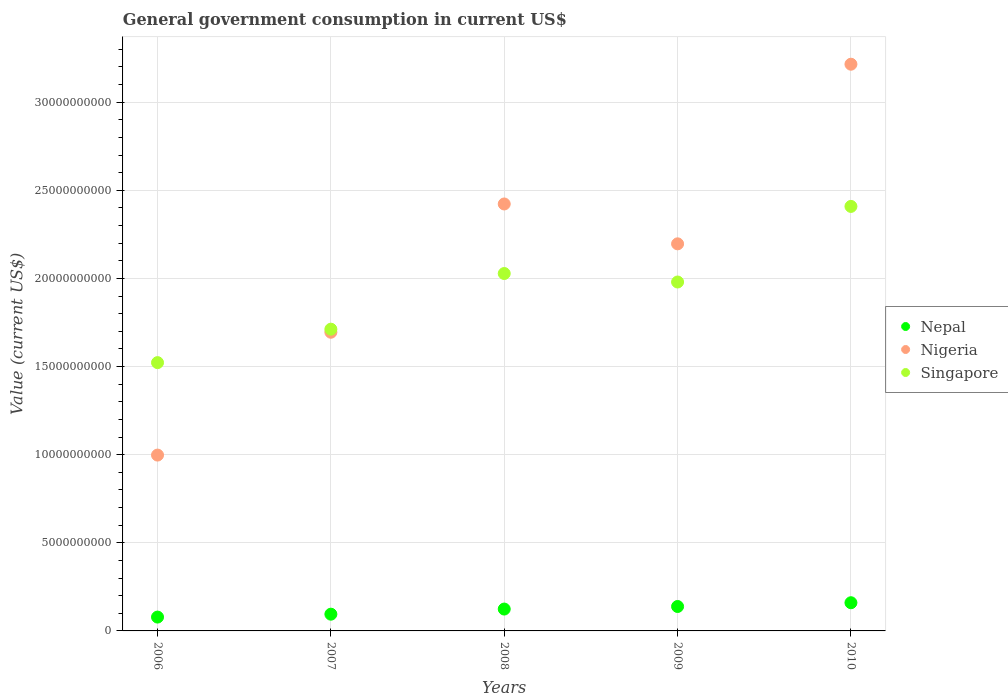How many different coloured dotlines are there?
Offer a terse response. 3. Is the number of dotlines equal to the number of legend labels?
Offer a very short reply. Yes. What is the government conusmption in Singapore in 2006?
Your answer should be very brief. 1.52e+1. Across all years, what is the maximum government conusmption in Nepal?
Give a very brief answer. 1.60e+09. Across all years, what is the minimum government conusmption in Singapore?
Your answer should be very brief. 1.52e+1. What is the total government conusmption in Nepal in the graph?
Your answer should be compact. 5.96e+09. What is the difference between the government conusmption in Singapore in 2009 and that in 2010?
Your response must be concise. -4.29e+09. What is the difference between the government conusmption in Singapore in 2009 and the government conusmption in Nepal in 2010?
Ensure brevity in your answer.  1.82e+1. What is the average government conusmption in Singapore per year?
Offer a terse response. 1.93e+1. In the year 2008, what is the difference between the government conusmption in Nepal and government conusmption in Nigeria?
Make the answer very short. -2.30e+1. In how many years, is the government conusmption in Nigeria greater than 16000000000 US$?
Offer a terse response. 4. What is the ratio of the government conusmption in Nepal in 2008 to that in 2009?
Keep it short and to the point. 0.9. Is the government conusmption in Singapore in 2006 less than that in 2007?
Provide a short and direct response. Yes. What is the difference between the highest and the second highest government conusmption in Nigeria?
Make the answer very short. 7.93e+09. What is the difference between the highest and the lowest government conusmption in Nigeria?
Ensure brevity in your answer.  2.22e+1. In how many years, is the government conusmption in Singapore greater than the average government conusmption in Singapore taken over all years?
Keep it short and to the point. 3. Is the sum of the government conusmption in Singapore in 2008 and 2010 greater than the maximum government conusmption in Nepal across all years?
Offer a very short reply. Yes. Does the government conusmption in Nigeria monotonically increase over the years?
Give a very brief answer. No. Is the government conusmption in Singapore strictly less than the government conusmption in Nigeria over the years?
Your response must be concise. No. How many years are there in the graph?
Keep it short and to the point. 5. What is the difference between two consecutive major ticks on the Y-axis?
Ensure brevity in your answer.  5.00e+09. Are the values on the major ticks of Y-axis written in scientific E-notation?
Your answer should be very brief. No. Where does the legend appear in the graph?
Give a very brief answer. Center right. How many legend labels are there?
Offer a very short reply. 3. How are the legend labels stacked?
Your answer should be very brief. Vertical. What is the title of the graph?
Offer a terse response. General government consumption in current US$. What is the label or title of the X-axis?
Make the answer very short. Years. What is the label or title of the Y-axis?
Your response must be concise. Value (current US$). What is the Value (current US$) of Nepal in 2006?
Your answer should be very brief. 7.85e+08. What is the Value (current US$) in Nigeria in 2006?
Ensure brevity in your answer.  9.98e+09. What is the Value (current US$) in Singapore in 2006?
Your answer should be very brief. 1.52e+1. What is the Value (current US$) in Nepal in 2007?
Your answer should be very brief. 9.50e+08. What is the Value (current US$) in Nigeria in 2007?
Your answer should be compact. 1.69e+1. What is the Value (current US$) of Singapore in 2007?
Offer a very short reply. 1.71e+1. What is the Value (current US$) of Nepal in 2008?
Offer a terse response. 1.24e+09. What is the Value (current US$) in Nigeria in 2008?
Provide a succinct answer. 2.42e+1. What is the Value (current US$) of Singapore in 2008?
Offer a very short reply. 2.03e+1. What is the Value (current US$) in Nepal in 2009?
Ensure brevity in your answer.  1.39e+09. What is the Value (current US$) of Nigeria in 2009?
Offer a terse response. 2.20e+1. What is the Value (current US$) in Singapore in 2009?
Your answer should be compact. 1.98e+1. What is the Value (current US$) of Nepal in 2010?
Make the answer very short. 1.60e+09. What is the Value (current US$) in Nigeria in 2010?
Give a very brief answer. 3.22e+1. What is the Value (current US$) in Singapore in 2010?
Your answer should be compact. 2.41e+1. Across all years, what is the maximum Value (current US$) of Nepal?
Offer a terse response. 1.60e+09. Across all years, what is the maximum Value (current US$) in Nigeria?
Your answer should be very brief. 3.22e+1. Across all years, what is the maximum Value (current US$) of Singapore?
Your answer should be compact. 2.41e+1. Across all years, what is the minimum Value (current US$) of Nepal?
Provide a succinct answer. 7.85e+08. Across all years, what is the minimum Value (current US$) of Nigeria?
Give a very brief answer. 9.98e+09. Across all years, what is the minimum Value (current US$) of Singapore?
Your response must be concise. 1.52e+1. What is the total Value (current US$) of Nepal in the graph?
Make the answer very short. 5.96e+09. What is the total Value (current US$) in Nigeria in the graph?
Give a very brief answer. 1.05e+11. What is the total Value (current US$) of Singapore in the graph?
Ensure brevity in your answer.  9.65e+1. What is the difference between the Value (current US$) in Nepal in 2006 and that in 2007?
Make the answer very short. -1.65e+08. What is the difference between the Value (current US$) of Nigeria in 2006 and that in 2007?
Your answer should be compact. -6.97e+09. What is the difference between the Value (current US$) in Singapore in 2006 and that in 2007?
Provide a short and direct response. -1.90e+09. What is the difference between the Value (current US$) of Nepal in 2006 and that in 2008?
Give a very brief answer. -4.55e+08. What is the difference between the Value (current US$) in Nigeria in 2006 and that in 2008?
Provide a short and direct response. -1.42e+1. What is the difference between the Value (current US$) in Singapore in 2006 and that in 2008?
Make the answer very short. -5.06e+09. What is the difference between the Value (current US$) in Nepal in 2006 and that in 2009?
Keep it short and to the point. -6.00e+08. What is the difference between the Value (current US$) in Nigeria in 2006 and that in 2009?
Your answer should be compact. -1.20e+1. What is the difference between the Value (current US$) in Singapore in 2006 and that in 2009?
Offer a terse response. -4.57e+09. What is the difference between the Value (current US$) of Nepal in 2006 and that in 2010?
Your answer should be very brief. -8.14e+08. What is the difference between the Value (current US$) of Nigeria in 2006 and that in 2010?
Provide a short and direct response. -2.22e+1. What is the difference between the Value (current US$) of Singapore in 2006 and that in 2010?
Make the answer very short. -8.86e+09. What is the difference between the Value (current US$) in Nepal in 2007 and that in 2008?
Give a very brief answer. -2.91e+08. What is the difference between the Value (current US$) of Nigeria in 2007 and that in 2008?
Your answer should be compact. -7.28e+09. What is the difference between the Value (current US$) in Singapore in 2007 and that in 2008?
Provide a short and direct response. -3.16e+09. What is the difference between the Value (current US$) of Nepal in 2007 and that in 2009?
Give a very brief answer. -4.36e+08. What is the difference between the Value (current US$) of Nigeria in 2007 and that in 2009?
Your answer should be very brief. -5.02e+09. What is the difference between the Value (current US$) of Singapore in 2007 and that in 2009?
Your response must be concise. -2.68e+09. What is the difference between the Value (current US$) in Nepal in 2007 and that in 2010?
Keep it short and to the point. -6.49e+08. What is the difference between the Value (current US$) in Nigeria in 2007 and that in 2010?
Your answer should be very brief. -1.52e+1. What is the difference between the Value (current US$) of Singapore in 2007 and that in 2010?
Ensure brevity in your answer.  -6.96e+09. What is the difference between the Value (current US$) of Nepal in 2008 and that in 2009?
Your answer should be very brief. -1.45e+08. What is the difference between the Value (current US$) in Nigeria in 2008 and that in 2009?
Provide a succinct answer. 2.26e+09. What is the difference between the Value (current US$) of Singapore in 2008 and that in 2009?
Provide a short and direct response. 4.82e+08. What is the difference between the Value (current US$) in Nepal in 2008 and that in 2010?
Give a very brief answer. -3.58e+08. What is the difference between the Value (current US$) of Nigeria in 2008 and that in 2010?
Provide a short and direct response. -7.93e+09. What is the difference between the Value (current US$) in Singapore in 2008 and that in 2010?
Keep it short and to the point. -3.81e+09. What is the difference between the Value (current US$) in Nepal in 2009 and that in 2010?
Your answer should be very brief. -2.13e+08. What is the difference between the Value (current US$) of Nigeria in 2009 and that in 2010?
Give a very brief answer. -1.02e+1. What is the difference between the Value (current US$) in Singapore in 2009 and that in 2010?
Ensure brevity in your answer.  -4.29e+09. What is the difference between the Value (current US$) of Nepal in 2006 and the Value (current US$) of Nigeria in 2007?
Ensure brevity in your answer.  -1.62e+1. What is the difference between the Value (current US$) in Nepal in 2006 and the Value (current US$) in Singapore in 2007?
Ensure brevity in your answer.  -1.63e+1. What is the difference between the Value (current US$) in Nigeria in 2006 and the Value (current US$) in Singapore in 2007?
Provide a short and direct response. -7.14e+09. What is the difference between the Value (current US$) in Nepal in 2006 and the Value (current US$) in Nigeria in 2008?
Your response must be concise. -2.34e+1. What is the difference between the Value (current US$) in Nepal in 2006 and the Value (current US$) in Singapore in 2008?
Your answer should be very brief. -1.95e+1. What is the difference between the Value (current US$) of Nigeria in 2006 and the Value (current US$) of Singapore in 2008?
Provide a succinct answer. -1.03e+1. What is the difference between the Value (current US$) of Nepal in 2006 and the Value (current US$) of Nigeria in 2009?
Offer a terse response. -2.12e+1. What is the difference between the Value (current US$) of Nepal in 2006 and the Value (current US$) of Singapore in 2009?
Offer a terse response. -1.90e+1. What is the difference between the Value (current US$) of Nigeria in 2006 and the Value (current US$) of Singapore in 2009?
Keep it short and to the point. -9.82e+09. What is the difference between the Value (current US$) in Nepal in 2006 and the Value (current US$) in Nigeria in 2010?
Offer a terse response. -3.14e+1. What is the difference between the Value (current US$) in Nepal in 2006 and the Value (current US$) in Singapore in 2010?
Offer a very short reply. -2.33e+1. What is the difference between the Value (current US$) in Nigeria in 2006 and the Value (current US$) in Singapore in 2010?
Give a very brief answer. -1.41e+1. What is the difference between the Value (current US$) of Nepal in 2007 and the Value (current US$) of Nigeria in 2008?
Provide a succinct answer. -2.33e+1. What is the difference between the Value (current US$) of Nepal in 2007 and the Value (current US$) of Singapore in 2008?
Offer a terse response. -1.93e+1. What is the difference between the Value (current US$) in Nigeria in 2007 and the Value (current US$) in Singapore in 2008?
Offer a terse response. -3.33e+09. What is the difference between the Value (current US$) of Nepal in 2007 and the Value (current US$) of Nigeria in 2009?
Offer a terse response. -2.10e+1. What is the difference between the Value (current US$) of Nepal in 2007 and the Value (current US$) of Singapore in 2009?
Ensure brevity in your answer.  -1.88e+1. What is the difference between the Value (current US$) of Nigeria in 2007 and the Value (current US$) of Singapore in 2009?
Your answer should be very brief. -2.85e+09. What is the difference between the Value (current US$) of Nepal in 2007 and the Value (current US$) of Nigeria in 2010?
Offer a terse response. -3.12e+1. What is the difference between the Value (current US$) in Nepal in 2007 and the Value (current US$) in Singapore in 2010?
Ensure brevity in your answer.  -2.31e+1. What is the difference between the Value (current US$) of Nigeria in 2007 and the Value (current US$) of Singapore in 2010?
Keep it short and to the point. -7.14e+09. What is the difference between the Value (current US$) in Nepal in 2008 and the Value (current US$) in Nigeria in 2009?
Give a very brief answer. -2.07e+1. What is the difference between the Value (current US$) of Nepal in 2008 and the Value (current US$) of Singapore in 2009?
Keep it short and to the point. -1.86e+1. What is the difference between the Value (current US$) of Nigeria in 2008 and the Value (current US$) of Singapore in 2009?
Give a very brief answer. 4.43e+09. What is the difference between the Value (current US$) in Nepal in 2008 and the Value (current US$) in Nigeria in 2010?
Your response must be concise. -3.09e+1. What is the difference between the Value (current US$) of Nepal in 2008 and the Value (current US$) of Singapore in 2010?
Offer a terse response. -2.28e+1. What is the difference between the Value (current US$) in Nigeria in 2008 and the Value (current US$) in Singapore in 2010?
Provide a short and direct response. 1.38e+08. What is the difference between the Value (current US$) of Nepal in 2009 and the Value (current US$) of Nigeria in 2010?
Make the answer very short. -3.08e+1. What is the difference between the Value (current US$) of Nepal in 2009 and the Value (current US$) of Singapore in 2010?
Provide a succinct answer. -2.27e+1. What is the difference between the Value (current US$) in Nigeria in 2009 and the Value (current US$) in Singapore in 2010?
Offer a terse response. -2.12e+09. What is the average Value (current US$) of Nepal per year?
Your answer should be very brief. 1.19e+09. What is the average Value (current US$) of Nigeria per year?
Provide a short and direct response. 2.11e+1. What is the average Value (current US$) in Singapore per year?
Offer a terse response. 1.93e+1. In the year 2006, what is the difference between the Value (current US$) of Nepal and Value (current US$) of Nigeria?
Your answer should be compact. -9.19e+09. In the year 2006, what is the difference between the Value (current US$) of Nepal and Value (current US$) of Singapore?
Keep it short and to the point. -1.44e+1. In the year 2006, what is the difference between the Value (current US$) in Nigeria and Value (current US$) in Singapore?
Ensure brevity in your answer.  -5.25e+09. In the year 2007, what is the difference between the Value (current US$) in Nepal and Value (current US$) in Nigeria?
Ensure brevity in your answer.  -1.60e+1. In the year 2007, what is the difference between the Value (current US$) of Nepal and Value (current US$) of Singapore?
Keep it short and to the point. -1.62e+1. In the year 2007, what is the difference between the Value (current US$) of Nigeria and Value (current US$) of Singapore?
Your response must be concise. -1.74e+08. In the year 2008, what is the difference between the Value (current US$) of Nepal and Value (current US$) of Nigeria?
Your answer should be compact. -2.30e+1. In the year 2008, what is the difference between the Value (current US$) of Nepal and Value (current US$) of Singapore?
Make the answer very short. -1.90e+1. In the year 2008, what is the difference between the Value (current US$) of Nigeria and Value (current US$) of Singapore?
Give a very brief answer. 3.95e+09. In the year 2009, what is the difference between the Value (current US$) of Nepal and Value (current US$) of Nigeria?
Ensure brevity in your answer.  -2.06e+1. In the year 2009, what is the difference between the Value (current US$) in Nepal and Value (current US$) in Singapore?
Provide a short and direct response. -1.84e+1. In the year 2009, what is the difference between the Value (current US$) of Nigeria and Value (current US$) of Singapore?
Offer a very short reply. 2.17e+09. In the year 2010, what is the difference between the Value (current US$) of Nepal and Value (current US$) of Nigeria?
Provide a succinct answer. -3.06e+1. In the year 2010, what is the difference between the Value (current US$) in Nepal and Value (current US$) in Singapore?
Your answer should be compact. -2.25e+1. In the year 2010, what is the difference between the Value (current US$) in Nigeria and Value (current US$) in Singapore?
Your answer should be very brief. 8.07e+09. What is the ratio of the Value (current US$) of Nepal in 2006 to that in 2007?
Offer a terse response. 0.83. What is the ratio of the Value (current US$) in Nigeria in 2006 to that in 2007?
Offer a very short reply. 0.59. What is the ratio of the Value (current US$) of Singapore in 2006 to that in 2007?
Offer a very short reply. 0.89. What is the ratio of the Value (current US$) of Nepal in 2006 to that in 2008?
Make the answer very short. 0.63. What is the ratio of the Value (current US$) of Nigeria in 2006 to that in 2008?
Offer a very short reply. 0.41. What is the ratio of the Value (current US$) of Singapore in 2006 to that in 2008?
Make the answer very short. 0.75. What is the ratio of the Value (current US$) in Nepal in 2006 to that in 2009?
Give a very brief answer. 0.57. What is the ratio of the Value (current US$) of Nigeria in 2006 to that in 2009?
Make the answer very short. 0.45. What is the ratio of the Value (current US$) in Singapore in 2006 to that in 2009?
Ensure brevity in your answer.  0.77. What is the ratio of the Value (current US$) in Nepal in 2006 to that in 2010?
Keep it short and to the point. 0.49. What is the ratio of the Value (current US$) in Nigeria in 2006 to that in 2010?
Provide a short and direct response. 0.31. What is the ratio of the Value (current US$) in Singapore in 2006 to that in 2010?
Offer a very short reply. 0.63. What is the ratio of the Value (current US$) of Nepal in 2007 to that in 2008?
Give a very brief answer. 0.77. What is the ratio of the Value (current US$) of Nigeria in 2007 to that in 2008?
Keep it short and to the point. 0.7. What is the ratio of the Value (current US$) in Singapore in 2007 to that in 2008?
Provide a succinct answer. 0.84. What is the ratio of the Value (current US$) in Nepal in 2007 to that in 2009?
Ensure brevity in your answer.  0.69. What is the ratio of the Value (current US$) in Nigeria in 2007 to that in 2009?
Provide a short and direct response. 0.77. What is the ratio of the Value (current US$) in Singapore in 2007 to that in 2009?
Your answer should be compact. 0.86. What is the ratio of the Value (current US$) of Nepal in 2007 to that in 2010?
Provide a short and direct response. 0.59. What is the ratio of the Value (current US$) in Nigeria in 2007 to that in 2010?
Ensure brevity in your answer.  0.53. What is the ratio of the Value (current US$) in Singapore in 2007 to that in 2010?
Provide a short and direct response. 0.71. What is the ratio of the Value (current US$) of Nepal in 2008 to that in 2009?
Offer a very short reply. 0.9. What is the ratio of the Value (current US$) in Nigeria in 2008 to that in 2009?
Provide a succinct answer. 1.1. What is the ratio of the Value (current US$) of Singapore in 2008 to that in 2009?
Keep it short and to the point. 1.02. What is the ratio of the Value (current US$) of Nepal in 2008 to that in 2010?
Provide a short and direct response. 0.78. What is the ratio of the Value (current US$) in Nigeria in 2008 to that in 2010?
Give a very brief answer. 0.75. What is the ratio of the Value (current US$) in Singapore in 2008 to that in 2010?
Provide a succinct answer. 0.84. What is the ratio of the Value (current US$) in Nepal in 2009 to that in 2010?
Give a very brief answer. 0.87. What is the ratio of the Value (current US$) of Nigeria in 2009 to that in 2010?
Offer a terse response. 0.68. What is the ratio of the Value (current US$) of Singapore in 2009 to that in 2010?
Give a very brief answer. 0.82. What is the difference between the highest and the second highest Value (current US$) of Nepal?
Provide a short and direct response. 2.13e+08. What is the difference between the highest and the second highest Value (current US$) of Nigeria?
Keep it short and to the point. 7.93e+09. What is the difference between the highest and the second highest Value (current US$) of Singapore?
Ensure brevity in your answer.  3.81e+09. What is the difference between the highest and the lowest Value (current US$) in Nepal?
Make the answer very short. 8.14e+08. What is the difference between the highest and the lowest Value (current US$) of Nigeria?
Give a very brief answer. 2.22e+1. What is the difference between the highest and the lowest Value (current US$) in Singapore?
Your response must be concise. 8.86e+09. 